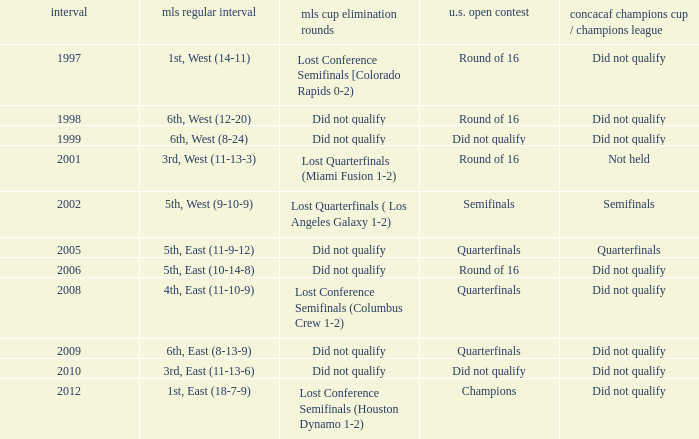What were the placements of the team in regular season when they reached quarterfinals in the U.S. Open Cup but did not qualify for the Concaf Champions Cup? 4th, East (11-10-9), 6th, East (8-13-9). 